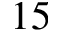<formula> <loc_0><loc_0><loc_500><loc_500>1 5</formula> 